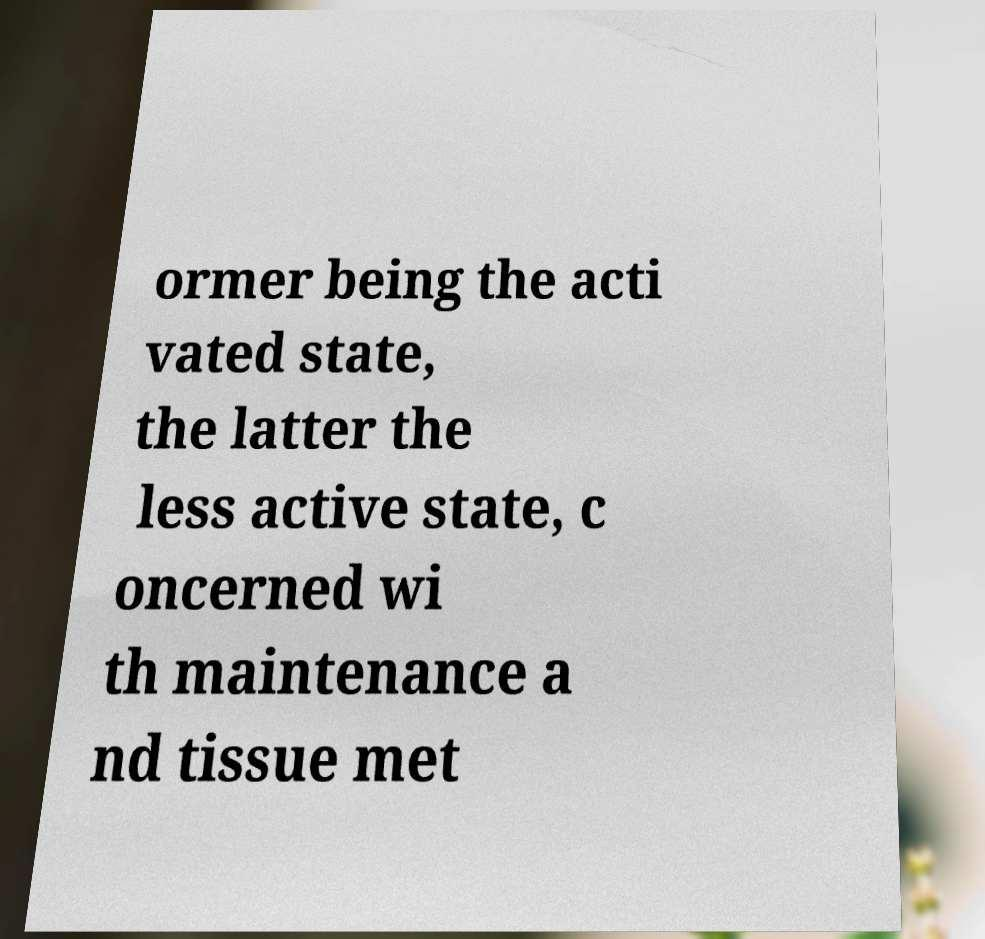I need the written content from this picture converted into text. Can you do that? ormer being the acti vated state, the latter the less active state, c oncerned wi th maintenance a nd tissue met 